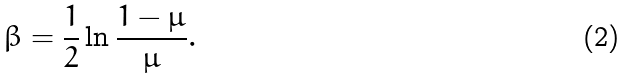<formula> <loc_0><loc_0><loc_500><loc_500>\beta = \frac { 1 } { 2 } \ln \frac { 1 - \mu } { \mu } .</formula> 